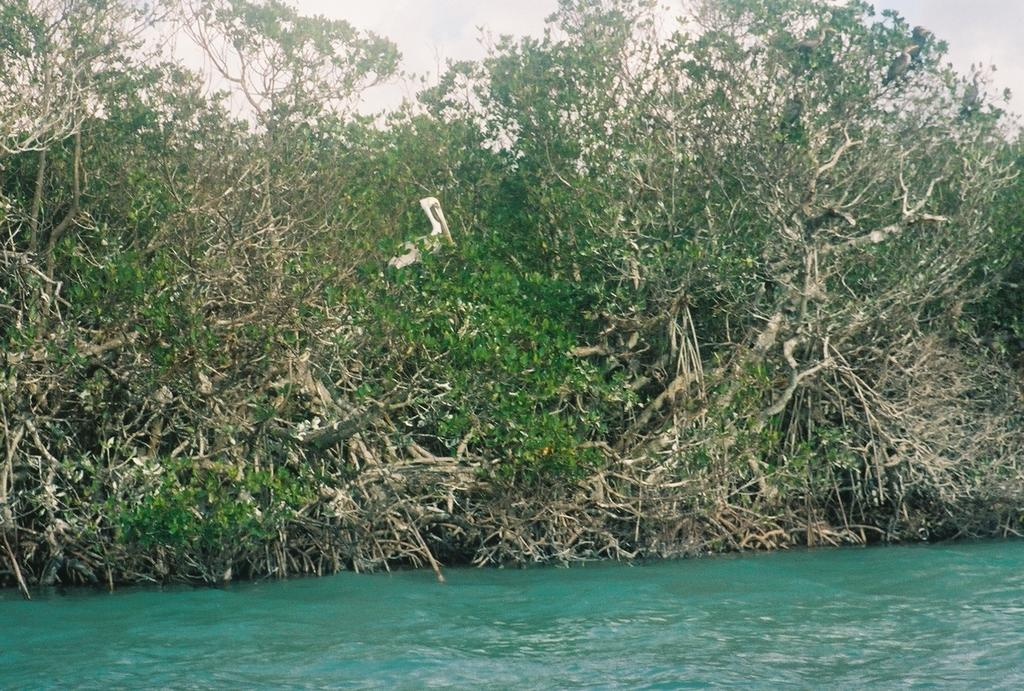What type of vegetation can be seen in the image? There are trees in the image. What is present at the bottom of the image? There is grass at the bottom of the image. What part of the natural environment is visible in the image? The sky is visible at the top of the image. What type of table can be seen in the image? There is no table present in the image. Is there any steam visible in the image? There is no steam present in the image. 